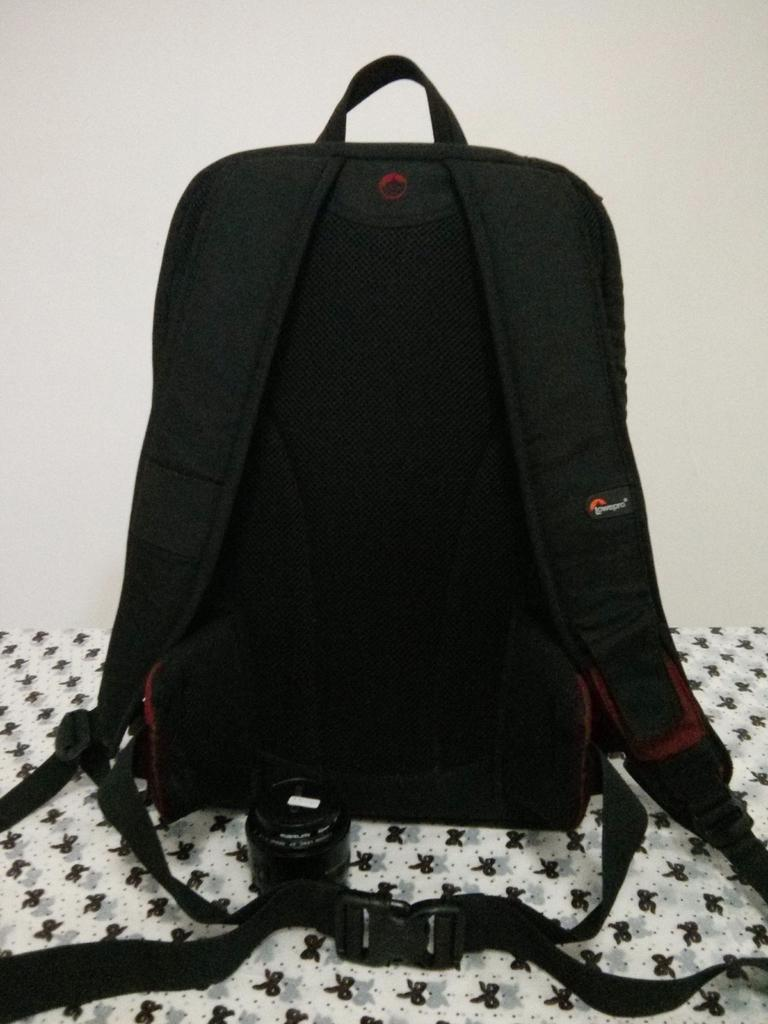What color is the bag in the image? The bag in the image is black colored. What can be seen in the background of the image? There is a cream colored wall in the background of the image. What type of fruit is growing in the basin in the image? There is no basin or fruit present in the image; it only features a black colored bag and a cream colored wall in the background. 